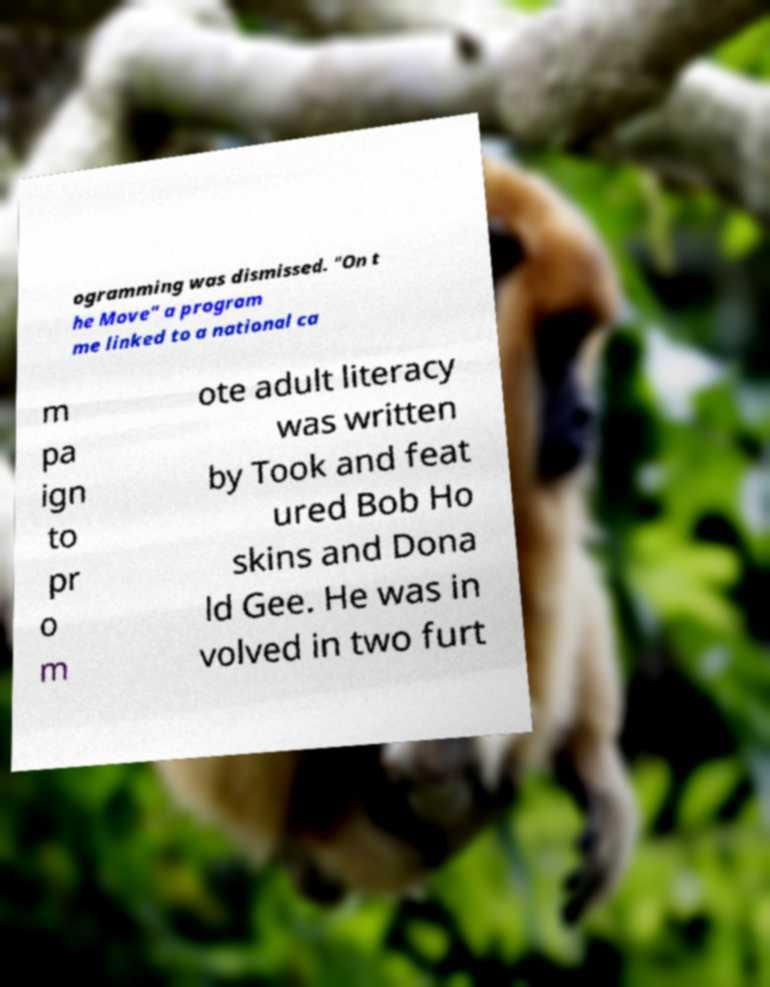For documentation purposes, I need the text within this image transcribed. Could you provide that? ogramming was dismissed. "On t he Move" a program me linked to a national ca m pa ign to pr o m ote adult literacy was written by Took and feat ured Bob Ho skins and Dona ld Gee. He was in volved in two furt 